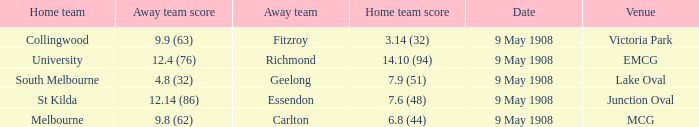Name the home team for carlton away team Melbourne. 